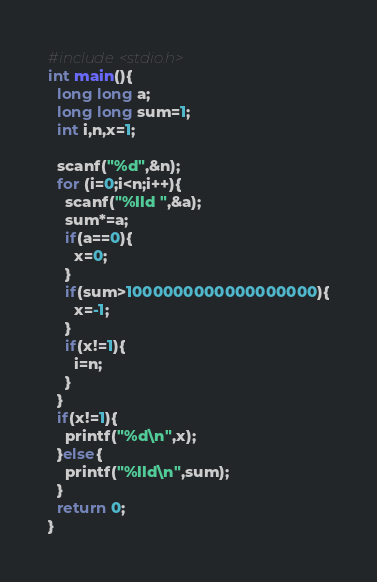<code> <loc_0><loc_0><loc_500><loc_500><_C_>#include<stdio.h>
int main(){
  long long a;
  long long sum=1;
  int i,n,x=1;
  
  scanf("%d",&n);
  for (i=0;i<n;i++){
  	scanf("%lld ",&a);
    sum*=a;
    if(a==0){
      x=0;
    }
    if(sum>1000000000000000000){
      x=-1;
    }
    if(x!=1){
      i=n;
    }
  }
  if(x!=1){
    printf("%d\n",x);
  }else{
    printf("%lld\n",sum);
  }
  return 0;
}</code> 